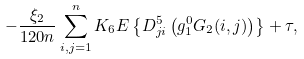<formula> <loc_0><loc_0><loc_500><loc_500>- \frac { \xi _ { 2 } } { 1 2 0 n } \sum _ { i , j = 1 } ^ { n } K _ { 6 } { E } \left \{ D ^ { 5 } _ { j i } \left ( g ^ { 0 } _ { 1 } G _ { 2 } ( i , j ) \right ) \right \} + \tau ,</formula> 